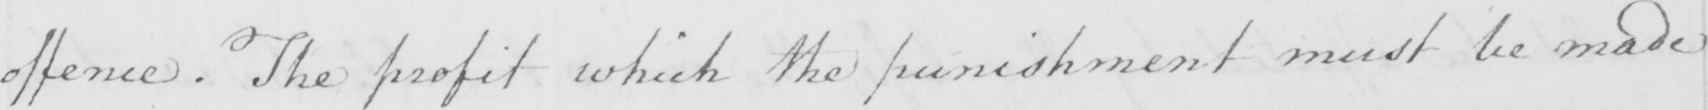Transcribe the text shown in this historical manuscript line. offence . The profit which the punishment must be made 